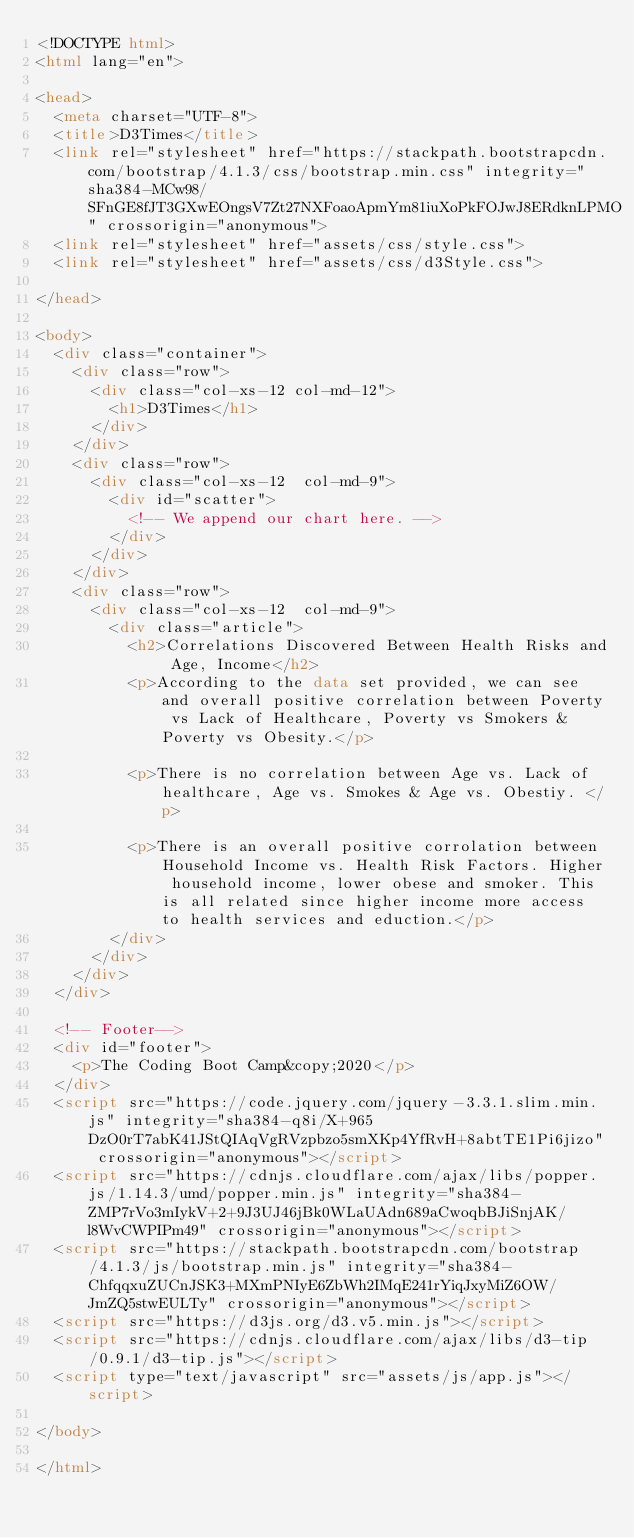Convert code to text. <code><loc_0><loc_0><loc_500><loc_500><_HTML_><!DOCTYPE html>
<html lang="en">

<head>
  <meta charset="UTF-8">
  <title>D3Times</title>
  <link rel="stylesheet" href="https://stackpath.bootstrapcdn.com/bootstrap/4.1.3/css/bootstrap.min.css" integrity="sha384-MCw98/SFnGE8fJT3GXwEOngsV7Zt27NXFoaoApmYm81iuXoPkFOJwJ8ERdknLPMO" crossorigin="anonymous">
  <link rel="stylesheet" href="assets/css/style.css">
  <link rel="stylesheet" href="assets/css/d3Style.css">

</head>

<body>
  <div class="container">
    <div class="row">
      <div class="col-xs-12 col-md-12">
        <h1>D3Times</h1>
      </div>
    </div>
    <div class="row">
      <div class="col-xs-12  col-md-9">
        <div id="scatter">
          <!-- We append our chart here. -->
        </div>
      </div>
    </div>
    <div class="row">
      <div class="col-xs-12  col-md-9">
        <div class="article">
          <h2>Correlations Discovered Between Health Risks and Age, Income</h2>
          <p>According to the data set provided, we can see and overall positive correlation between Poverty vs Lack of Healthcare, Poverty vs Smokers & Poverty vs Obesity.</p>

          <p>There is no correlation between Age vs. Lack of healthcare, Age vs. Smokes & Age vs. Obestiy. </p>

          <p>There is an overall positive corrolation between Household Income vs. Health Risk Factors. Higher household income, lower obese and smoker. This is all related since higher income more access to health services and eduction.</p>
        </div>
      </div>
    </div>
  </div>

  <!-- Footer-->
  <div id="footer">
    <p>The Coding Boot Camp&copy;2020</p>
  </div>
  <script src="https://code.jquery.com/jquery-3.3.1.slim.min.js" integrity="sha384-q8i/X+965DzO0rT7abK41JStQIAqVgRVzpbzo5smXKp4YfRvH+8abtTE1Pi6jizo" crossorigin="anonymous"></script>
  <script src="https://cdnjs.cloudflare.com/ajax/libs/popper.js/1.14.3/umd/popper.min.js" integrity="sha384-ZMP7rVo3mIykV+2+9J3UJ46jBk0WLaUAdn689aCwoqbBJiSnjAK/l8WvCWPIPm49" crossorigin="anonymous"></script>
  <script src="https://stackpath.bootstrapcdn.com/bootstrap/4.1.3/js/bootstrap.min.js" integrity="sha384-ChfqqxuZUCnJSK3+MXmPNIyE6ZbWh2IMqE241rYiqJxyMiZ6OW/JmZQ5stwEULTy" crossorigin="anonymous"></script>
  <script src="https://d3js.org/d3.v5.min.js"></script>
  <script src="https://cdnjs.cloudflare.com/ajax/libs/d3-tip/0.9.1/d3-tip.js"></script>
  <script type="text/javascript" src="assets/js/app.js"></script>

</body>

</html></code> 